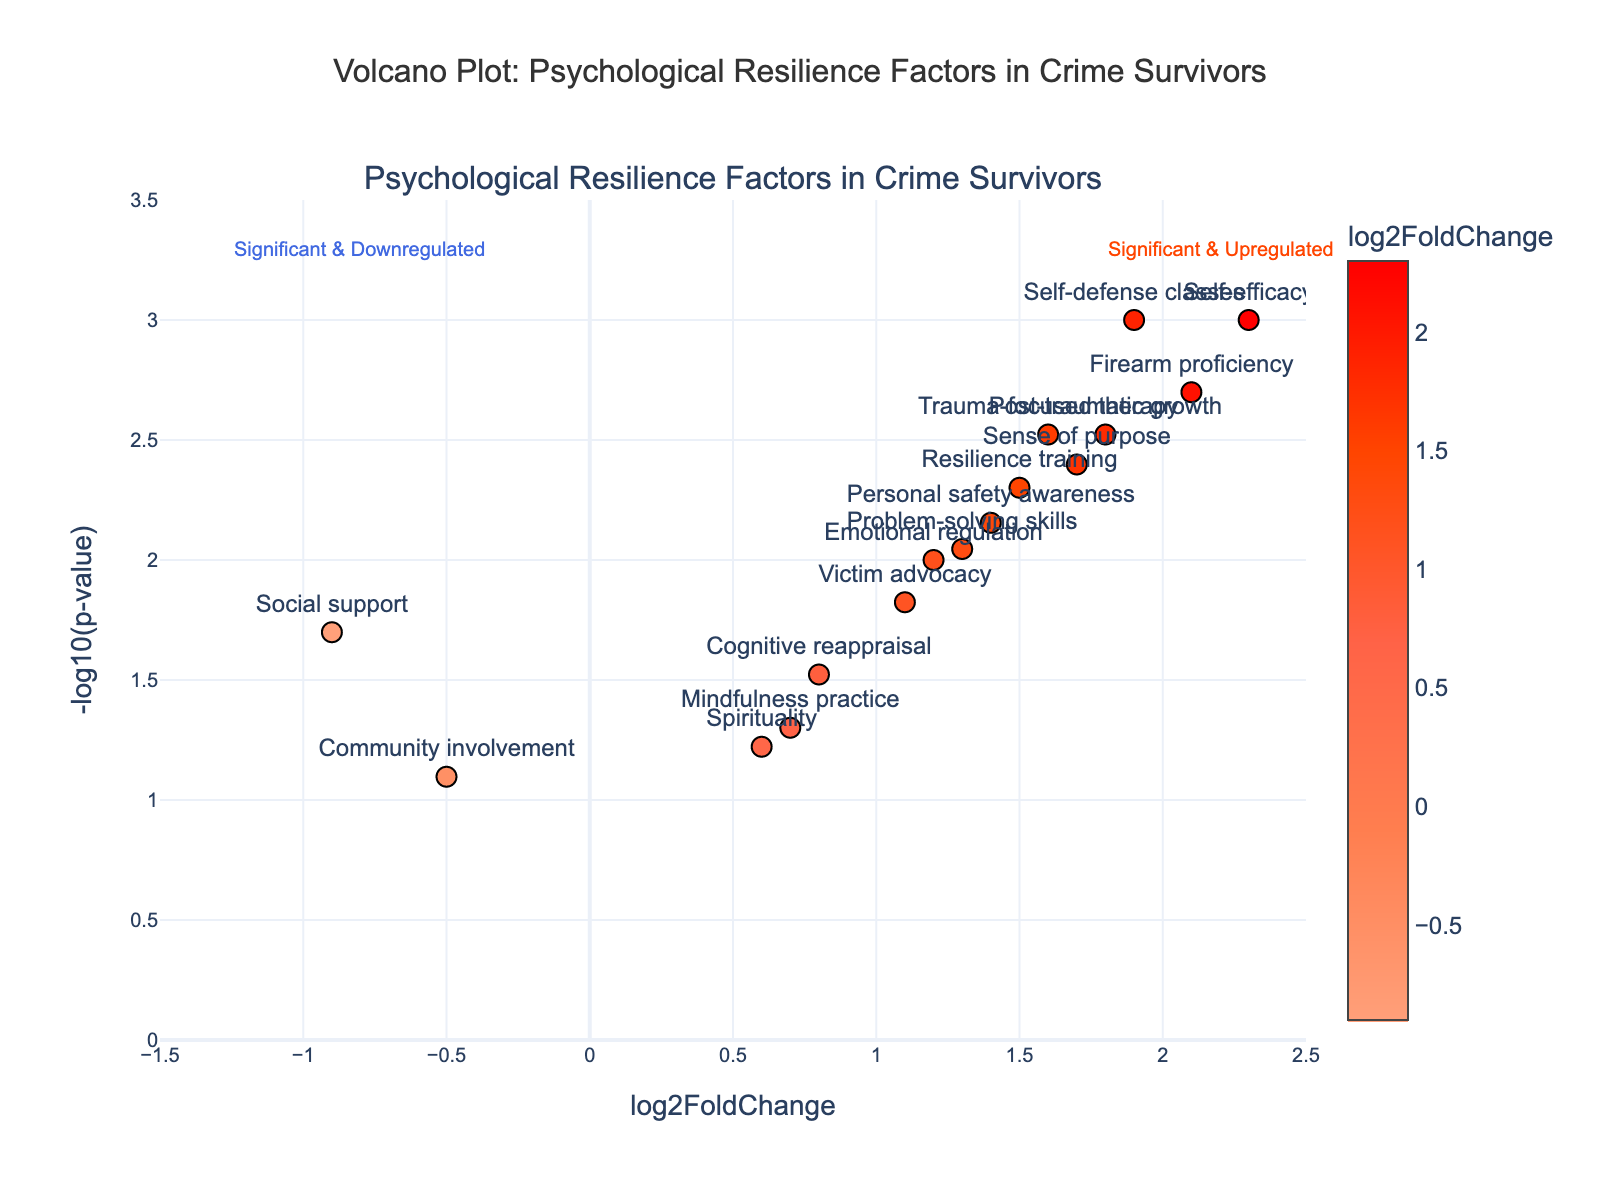What is the title of the plot? The title can be found at the top of the plot. It reads "Volcano Plot: Psychological Resilience Factors in Crime Survivors".
Answer: Volcano Plot: Psychological Resilience Factors in Crime Survivors What is the range of the x-axis (log2FoldChange)? By examining the x-axis, it ranges from -1.5 to 2.5.
Answer: -1.5 to 2.5 Which psychological resilience factor has the highest log2FoldChange? By looking at the scatter points, the factor with the highest log2FoldChange is "Self-efficacy" with a log2FoldChange of 2.3.
Answer: Self-efficacy How many factors have a p-value less than 0.01? The factors with a p-value less than 0.01 will have a -log10(p-value) greater than 2. By counting these points on the y-axis, there are six: Self-efficacy, Firearm proficiency, Self-defense classes, Post-traumatic growth, Sense of purpose, and Resilience training.
Answer: 6 Which factors are significantly upregulated? Points in the right half (positive log2FoldChange) and above the threshold line (-log10(p-value)) indicate significant upregulation. These include Self-efficacy, Firearm proficiency, Self-defense classes, Post-traumatic growth, Sense of purpose, Resilience training, and Personal safety awareness.
Answer: Self-efficacy, Firearm proficiency, Self-defense classes, Post-traumatic growth, Sense of purpose, Resilience training, Personal safety awareness Are there any factors that are downregulated? Downregulated factors have a negative log2FoldChange. There are two such factors, "Social support" and "Community involvement".
Answer: Social support, Community involvement Which factor shows the smallest upregulation but still has a significant p-value? By looking at the lowest positive log2FoldChange values that are still above the significance threshold (-log10(p-value) > ~2), "Emotional regulation" appears the smallest with a log2FoldChange of 1.2.
Answer: Emotional regulation What is the p-value for the "Problem-solving skills" factor? By referring to the plot, the hover text indicates the p-value for "Problem-solving skills", which is 0.009.
Answer: 0.009 Which point represents resilience training, and where is it located? The factor "Resilience training" is marked on the plot with a text label and shows a log2FoldChange of 1.5. It is located to the right and above the middle of the plot.
Answer: 1.5 log2FoldChange, ~2.3 -log10(p-value) What annotation is added to the plot and where? There are two annotations: "Significant & Upregulated" at (2.2, 3.3) and "Significant & Downregulated" at (-0.8, 3.3).
Answer: Significant & Upregulated at (2.2, 3.3), Significant & Downregulated at (-0.8, 3.3) 